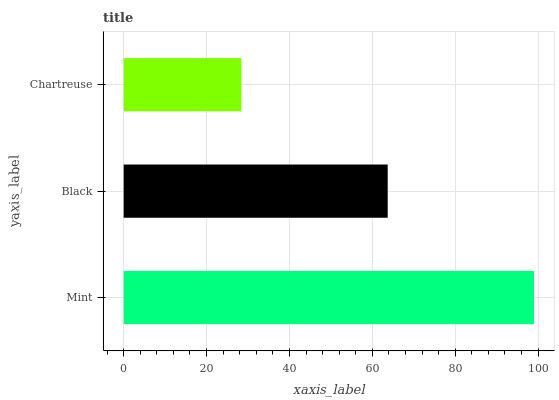Is Chartreuse the minimum?
Answer yes or no. Yes. Is Mint the maximum?
Answer yes or no. Yes. Is Black the minimum?
Answer yes or no. No. Is Black the maximum?
Answer yes or no. No. Is Mint greater than Black?
Answer yes or no. Yes. Is Black less than Mint?
Answer yes or no. Yes. Is Black greater than Mint?
Answer yes or no. No. Is Mint less than Black?
Answer yes or no. No. Is Black the high median?
Answer yes or no. Yes. Is Black the low median?
Answer yes or no. Yes. Is Mint the high median?
Answer yes or no. No. Is Mint the low median?
Answer yes or no. No. 